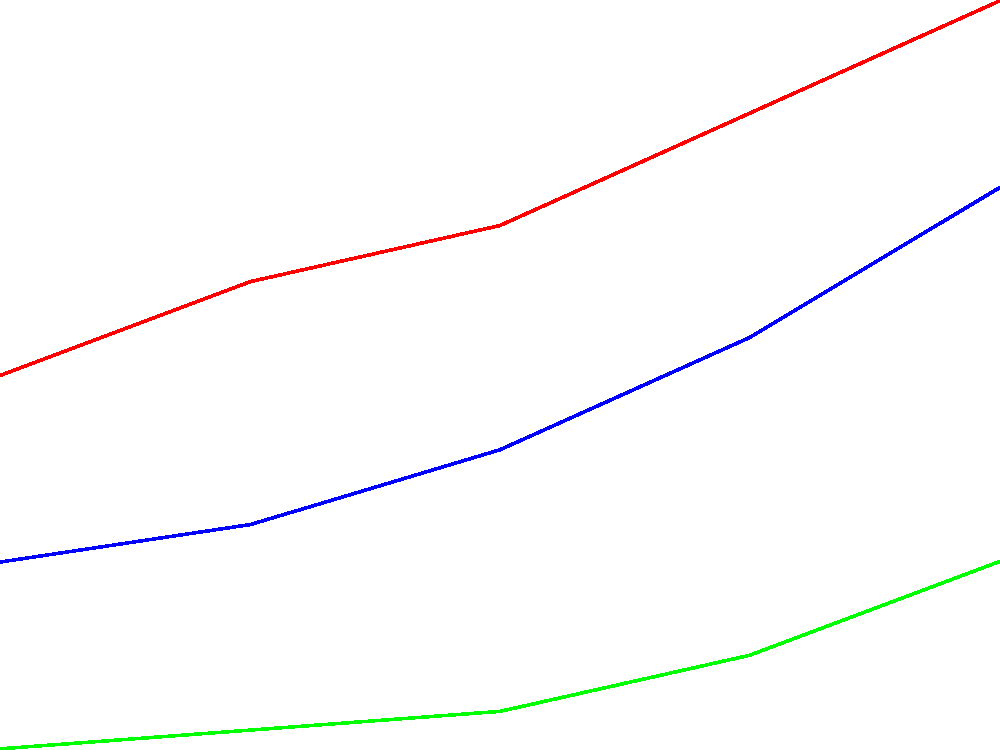Based on the line graph showing property value trends from 2018 to 2022, which area experienced the highest percentage increase in property value, and what was the approximate percentage increase? To determine the area with the highest percentage increase and calculate it:

1. Calculate the percentage increase for each area:

   Downtown:
   Initial value (2018): $250,000
   Final value (2022): $350,000
   Percentage increase = (350,000 - 250,000) / 250,000 * 100 = 40%

   Suburban:
   Initial value (2018): $200,000
   Final value (2022): $300,000
   Percentage increase = (300,000 - 200,000) / 200,000 * 100 = 50%

   Rural:
   Initial value (2018): $150,000
   Final value (2022): $200,000
   Percentage increase = (200,000 - 150,000) / 150,000 * 100 = 33.33%

2. Compare the percentage increases:
   Suburban: 50%
   Downtown: 40%
   Rural: 33.33%

3. Identify the highest percentage increase:
   The suburban area had the highest percentage increase at 50%.
Answer: Suburban area, 50% 